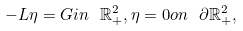Convert formula to latex. <formula><loc_0><loc_0><loc_500><loc_500>- L \eta = G i n \ \mathbb { R } ^ { 2 } _ { + } , \eta = 0 o n \ \partial \mathbb { R } ^ { 2 } _ { + } ,</formula> 